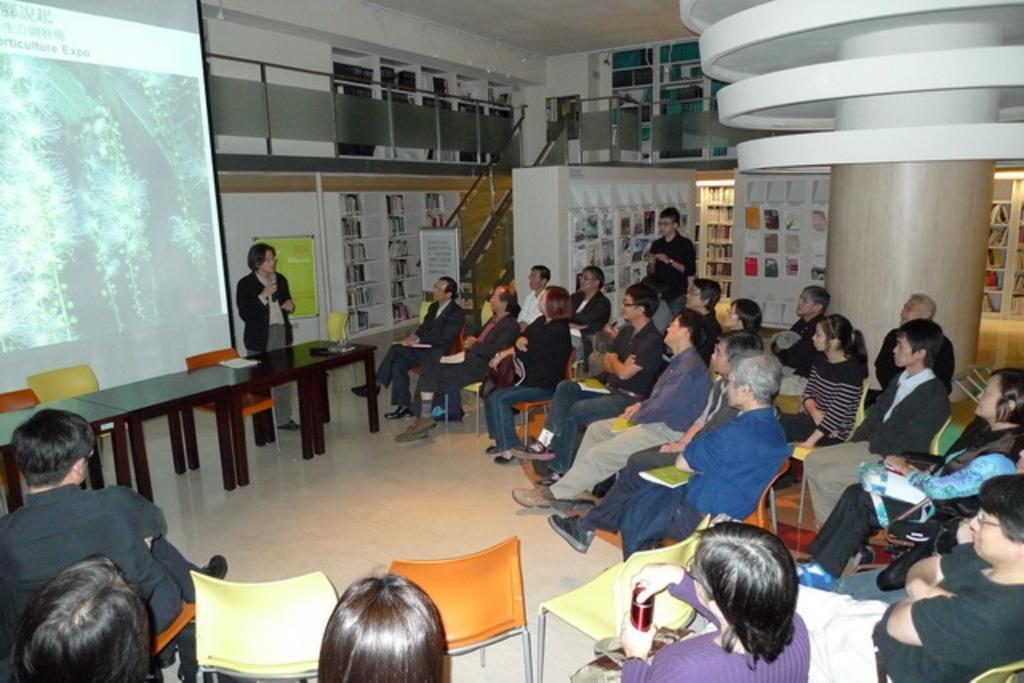How would you summarize this image in a sentence or two? In this picture there are people sitting on chairs and two people standing and we can see objects on the table, pillar, boards, floor and objects. In the background of the image we can see screen, railings, wall and objects in racks. 